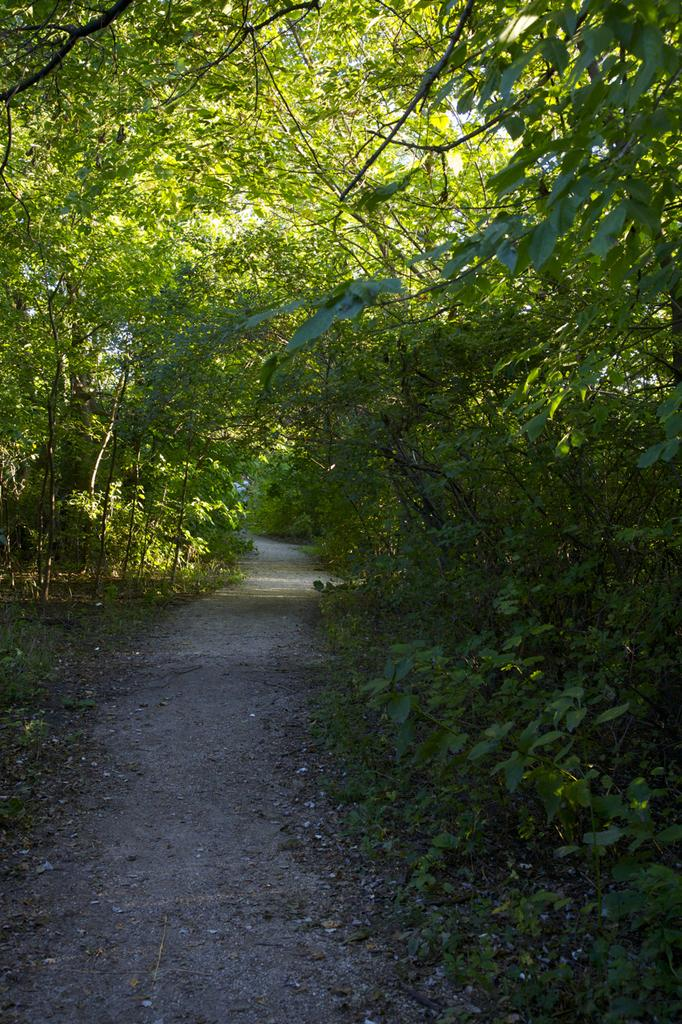What is the main subject of the image? The main subject of the image is a way. What can be seen on one side of the way? There are plants on one side of the way. What can be seen on the other side of the way? There are trees on the other side of the way. What type of ice can be seen melting on the way in the image? There is no ice present in the image; it features a way with plants on one side and trees on the other side. Can you describe the substance that the visitor is carrying in the image? There is no visitor present in the image, so it is not possible to describe any substance they might be carrying. 